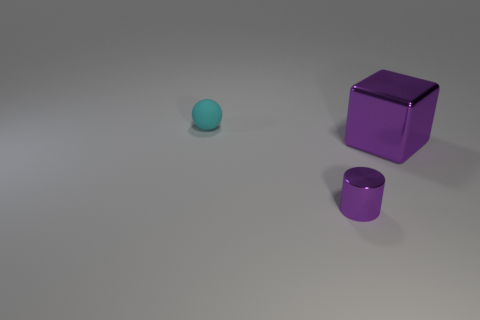The thing that is both behind the tiny purple metallic cylinder and right of the rubber object has what shape?
Offer a very short reply. Cube. Is the number of tiny purple cylinders behind the purple metallic cube less than the number of tiny objects?
Ensure brevity in your answer.  Yes. How many big things are either metallic cylinders or purple cubes?
Provide a short and direct response. 1. What size is the matte object?
Offer a very short reply. Small. Is there any other thing that has the same material as the purple cylinder?
Provide a short and direct response. Yes. How many small things are right of the small purple object?
Offer a very short reply. 0. What size is the object that is left of the large purple shiny thing and behind the small purple cylinder?
Your answer should be very brief. Small. Is the color of the small cylinder the same as the thing behind the purple shiny block?
Provide a succinct answer. No. How many purple objects are small rubber objects or metallic blocks?
Your answer should be very brief. 1. The tiny purple thing has what shape?
Provide a short and direct response. Cylinder. 